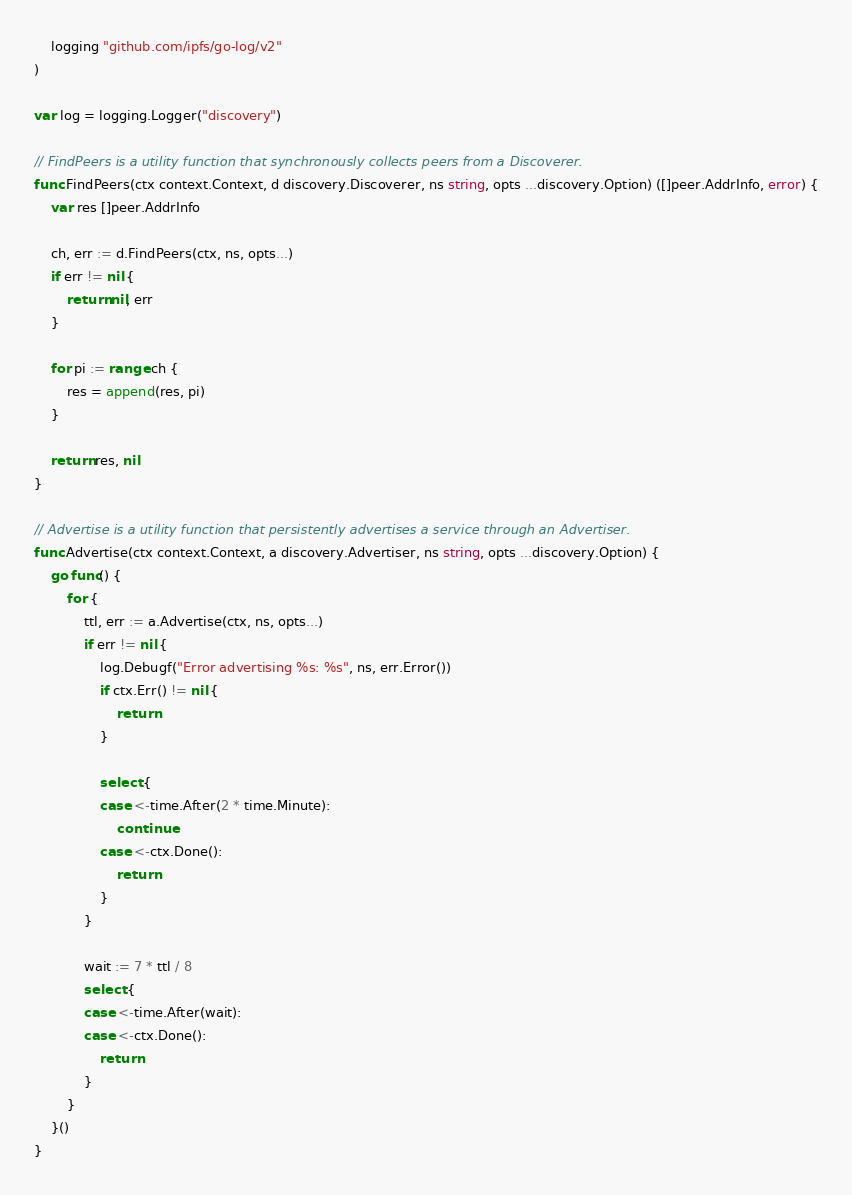<code> <loc_0><loc_0><loc_500><loc_500><_Go_>
	logging "github.com/ipfs/go-log/v2"
)

var log = logging.Logger("discovery")

// FindPeers is a utility function that synchronously collects peers from a Discoverer.
func FindPeers(ctx context.Context, d discovery.Discoverer, ns string, opts ...discovery.Option) ([]peer.AddrInfo, error) {
	var res []peer.AddrInfo

	ch, err := d.FindPeers(ctx, ns, opts...)
	if err != nil {
		return nil, err
	}

	for pi := range ch {
		res = append(res, pi)
	}

	return res, nil
}

// Advertise is a utility function that persistently advertises a service through an Advertiser.
func Advertise(ctx context.Context, a discovery.Advertiser, ns string, opts ...discovery.Option) {
	go func() {
		for {
			ttl, err := a.Advertise(ctx, ns, opts...)
			if err != nil {
				log.Debugf("Error advertising %s: %s", ns, err.Error())
				if ctx.Err() != nil {
					return
				}

				select {
				case <-time.After(2 * time.Minute):
					continue
				case <-ctx.Done():
					return
				}
			}

			wait := 7 * ttl / 8
			select {
			case <-time.After(wait):
			case <-ctx.Done():
				return
			}
		}
	}()
}
</code> 